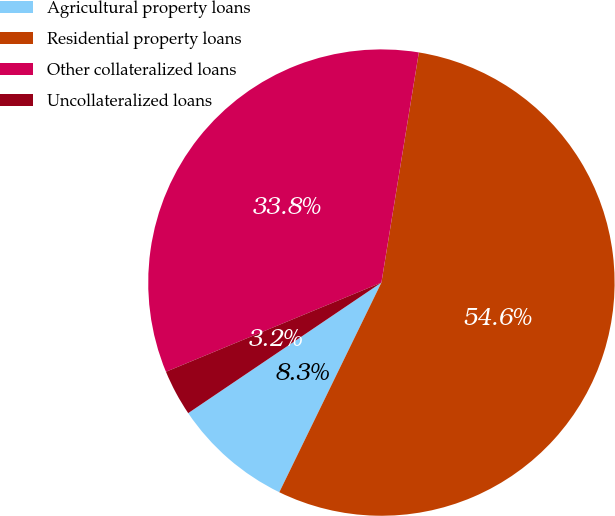Convert chart. <chart><loc_0><loc_0><loc_500><loc_500><pie_chart><fcel>Agricultural property loans<fcel>Residential property loans<fcel>Other collateralized loans<fcel>Uncollateralized loans<nl><fcel>8.33%<fcel>54.64%<fcel>33.81%<fcel>3.21%<nl></chart> 